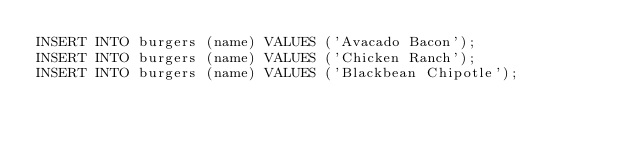Convert code to text. <code><loc_0><loc_0><loc_500><loc_500><_SQL_>INSERT INTO burgers (name) VALUES ('Avacado Bacon');
INSERT INTO burgers (name) VALUES ('Chicken Ranch');
INSERT INTO burgers (name) VALUES ('Blackbean Chipotle');
</code> 